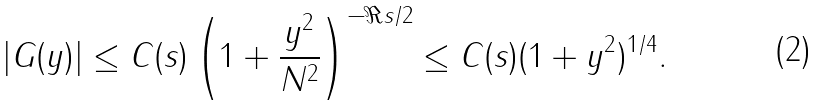Convert formula to latex. <formula><loc_0><loc_0><loc_500><loc_500>| G ( y ) | \leq C ( s ) \left ( 1 + \frac { y ^ { 2 } } { N ^ { 2 } } \right ) ^ { - \Re { s } / 2 } \leq C ( s ) ( 1 + y ^ { 2 } ) ^ { 1 / 4 } .</formula> 